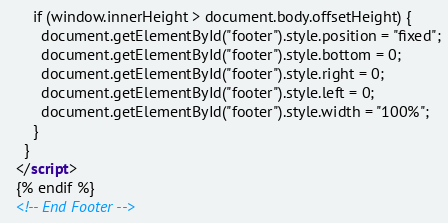<code> <loc_0><loc_0><loc_500><loc_500><_HTML_>      if (window.innerHeight > document.body.offsetHeight) {
        document.getElementById("footer").style.position = "fixed";
        document.getElementById("footer").style.bottom = 0;
        document.getElementById("footer").style.right = 0;
        document.getElementById("footer").style.left = 0;
        document.getElementById("footer").style.width = "100%";
      }
    }
  </script>
  {% endif %}
  <!-- End Footer --></code> 